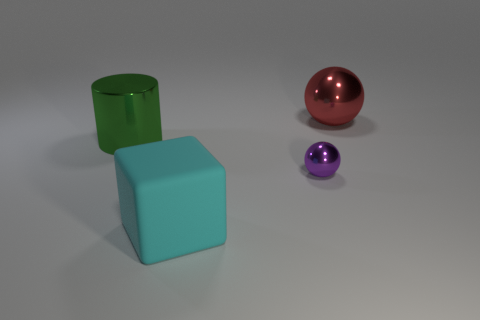What color is the small ball?
Your response must be concise. Purple. Are there any other things that are the same color as the cylinder?
Your answer should be very brief. No. What is the color of the metallic object that is both behind the small thing and left of the red metallic thing?
Make the answer very short. Green. Do the object that is right of the purple sphere and the small ball have the same size?
Keep it short and to the point. No. Are there more large shiny objects that are to the right of the big cyan matte cube than small cyan rubber cylinders?
Give a very brief answer. Yes. Do the big red metallic thing and the tiny metal thing have the same shape?
Ensure brevity in your answer.  Yes. The purple ball is what size?
Offer a terse response. Small. Are there more metallic objects left of the rubber cube than green cylinders right of the red shiny ball?
Provide a succinct answer. Yes. Are there any metal balls in front of the big cylinder?
Keep it short and to the point. Yes. Is there a green rubber cylinder of the same size as the red metallic object?
Ensure brevity in your answer.  No. 